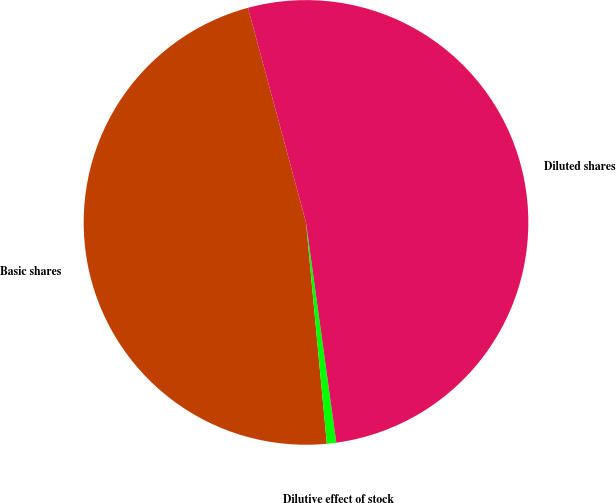<chart> <loc_0><loc_0><loc_500><loc_500><pie_chart><fcel>Basic shares<fcel>Dilutive effect of stock<fcel>Diluted shares<nl><fcel>47.3%<fcel>0.68%<fcel>52.03%<nl></chart> 